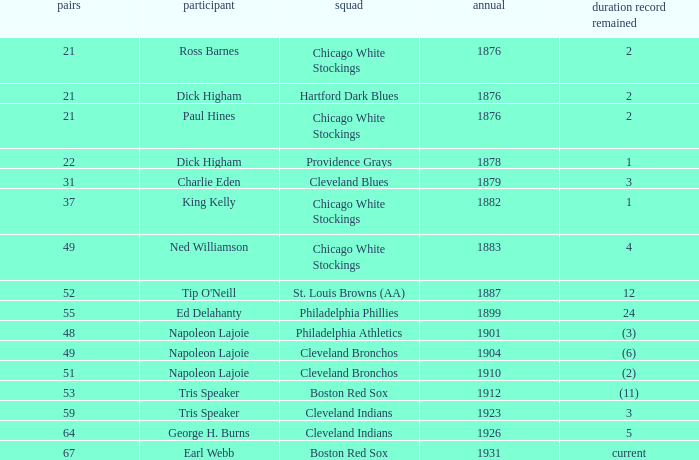Player of napoleon lajoie, and a Team of cleveland bronchos, and a Doubles of 49 which years record stood? (6). 